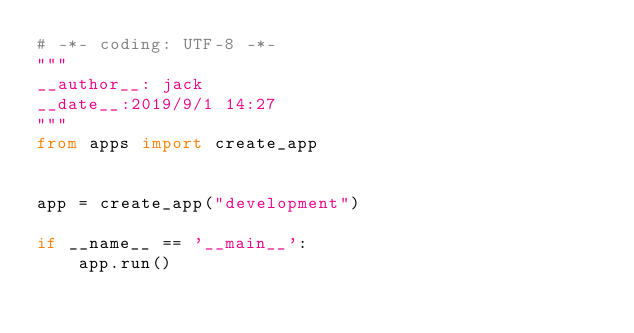<code> <loc_0><loc_0><loc_500><loc_500><_Python_># -*- coding: UTF-8 -*-
"""
__author__: jack
__date__:2019/9/1 14:27
"""
from apps import create_app


app = create_app("development")

if __name__ == '__main__':
    app.run()</code> 